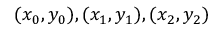<formula> <loc_0><loc_0><loc_500><loc_500>( x _ { 0 } , y _ { 0 } ) , ( x _ { 1 } , y _ { 1 } ) , ( x _ { 2 } , y _ { 2 } )</formula> 